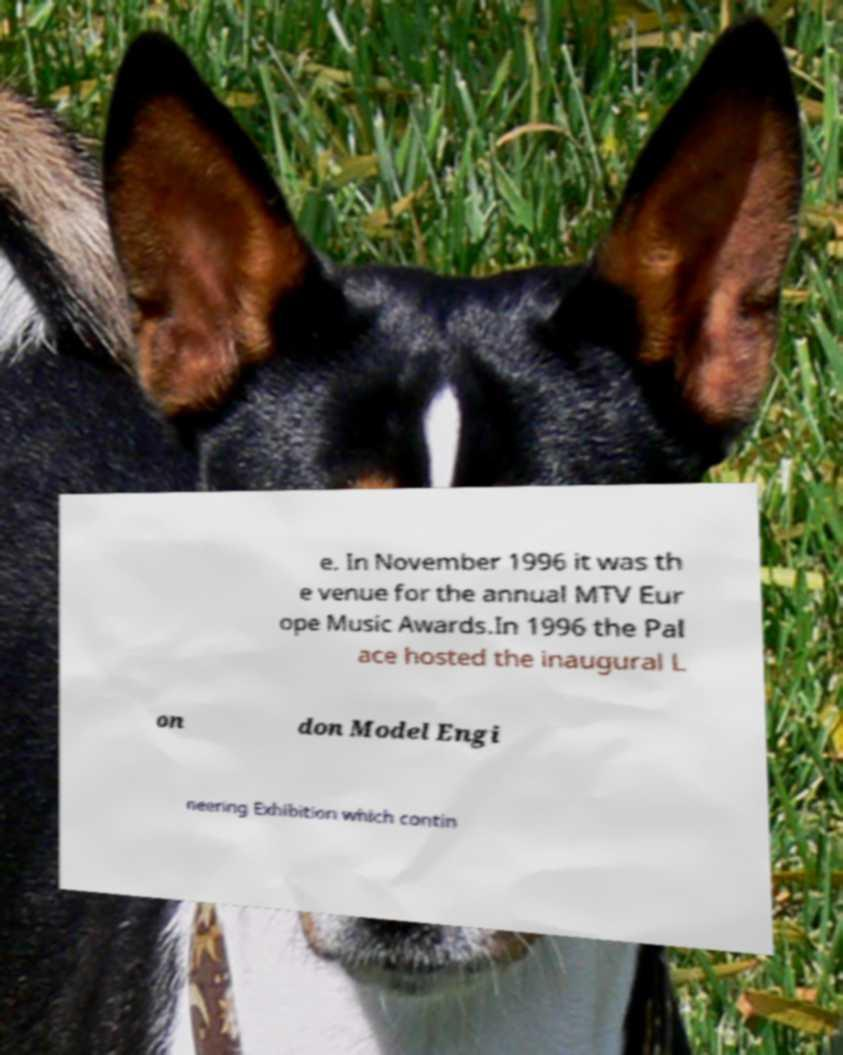I need the written content from this picture converted into text. Can you do that? e. In November 1996 it was th e venue for the annual MTV Eur ope Music Awards.In 1996 the Pal ace hosted the inaugural L on don Model Engi neering Exhibition which contin 